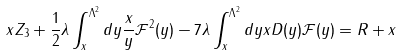Convert formula to latex. <formula><loc_0><loc_0><loc_500><loc_500>x Z _ { 3 } + \frac { 1 } { 2 } \lambda \int _ { x } ^ { \Lambda ^ { 2 } } { d y } \frac { x } { y } { \mathcal { F } } ^ { 2 } ( y ) - 7 \lambda \int _ { x } ^ { \Lambda ^ { 2 } } d y x D ( y ) { \mathcal { F } } ( y ) = R + x</formula> 